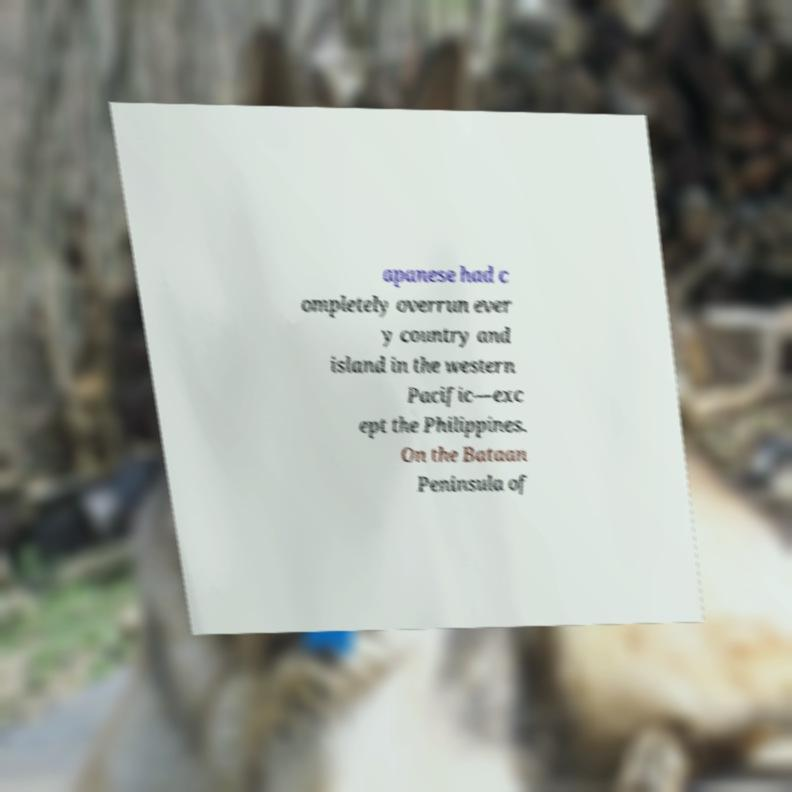Could you extract and type out the text from this image? apanese had c ompletely overrun ever y country and island in the western Pacific—exc ept the Philippines. On the Bataan Peninsula of 